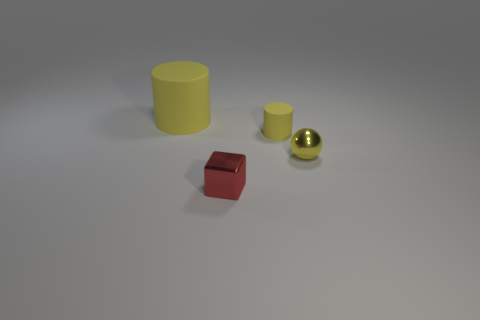How many other objects are there of the same color as the tiny matte cylinder?
Your answer should be compact. 2. How many things are yellow matte cylinders behind the small red metallic block or small red blocks to the left of the small matte cylinder?
Keep it short and to the point. 3. How big is the shiny thing in front of the metallic object to the right of the tiny red metal thing?
Provide a succinct answer. Small. The yellow ball has what size?
Provide a succinct answer. Small. There is a metal thing right of the small metal block; does it have the same color as the metallic thing that is in front of the yellow metallic sphere?
Keep it short and to the point. No. How many other things are the same material as the large yellow object?
Your answer should be very brief. 1. Are any tiny purple rubber blocks visible?
Offer a terse response. No. Are the cylinder that is on the left side of the tiny red shiny cube and the tiny red thing made of the same material?
Make the answer very short. No. There is another yellow thing that is the same shape as the large object; what material is it?
Your answer should be compact. Rubber. What material is the tiny object that is the same color as the small rubber cylinder?
Your answer should be compact. Metal. 